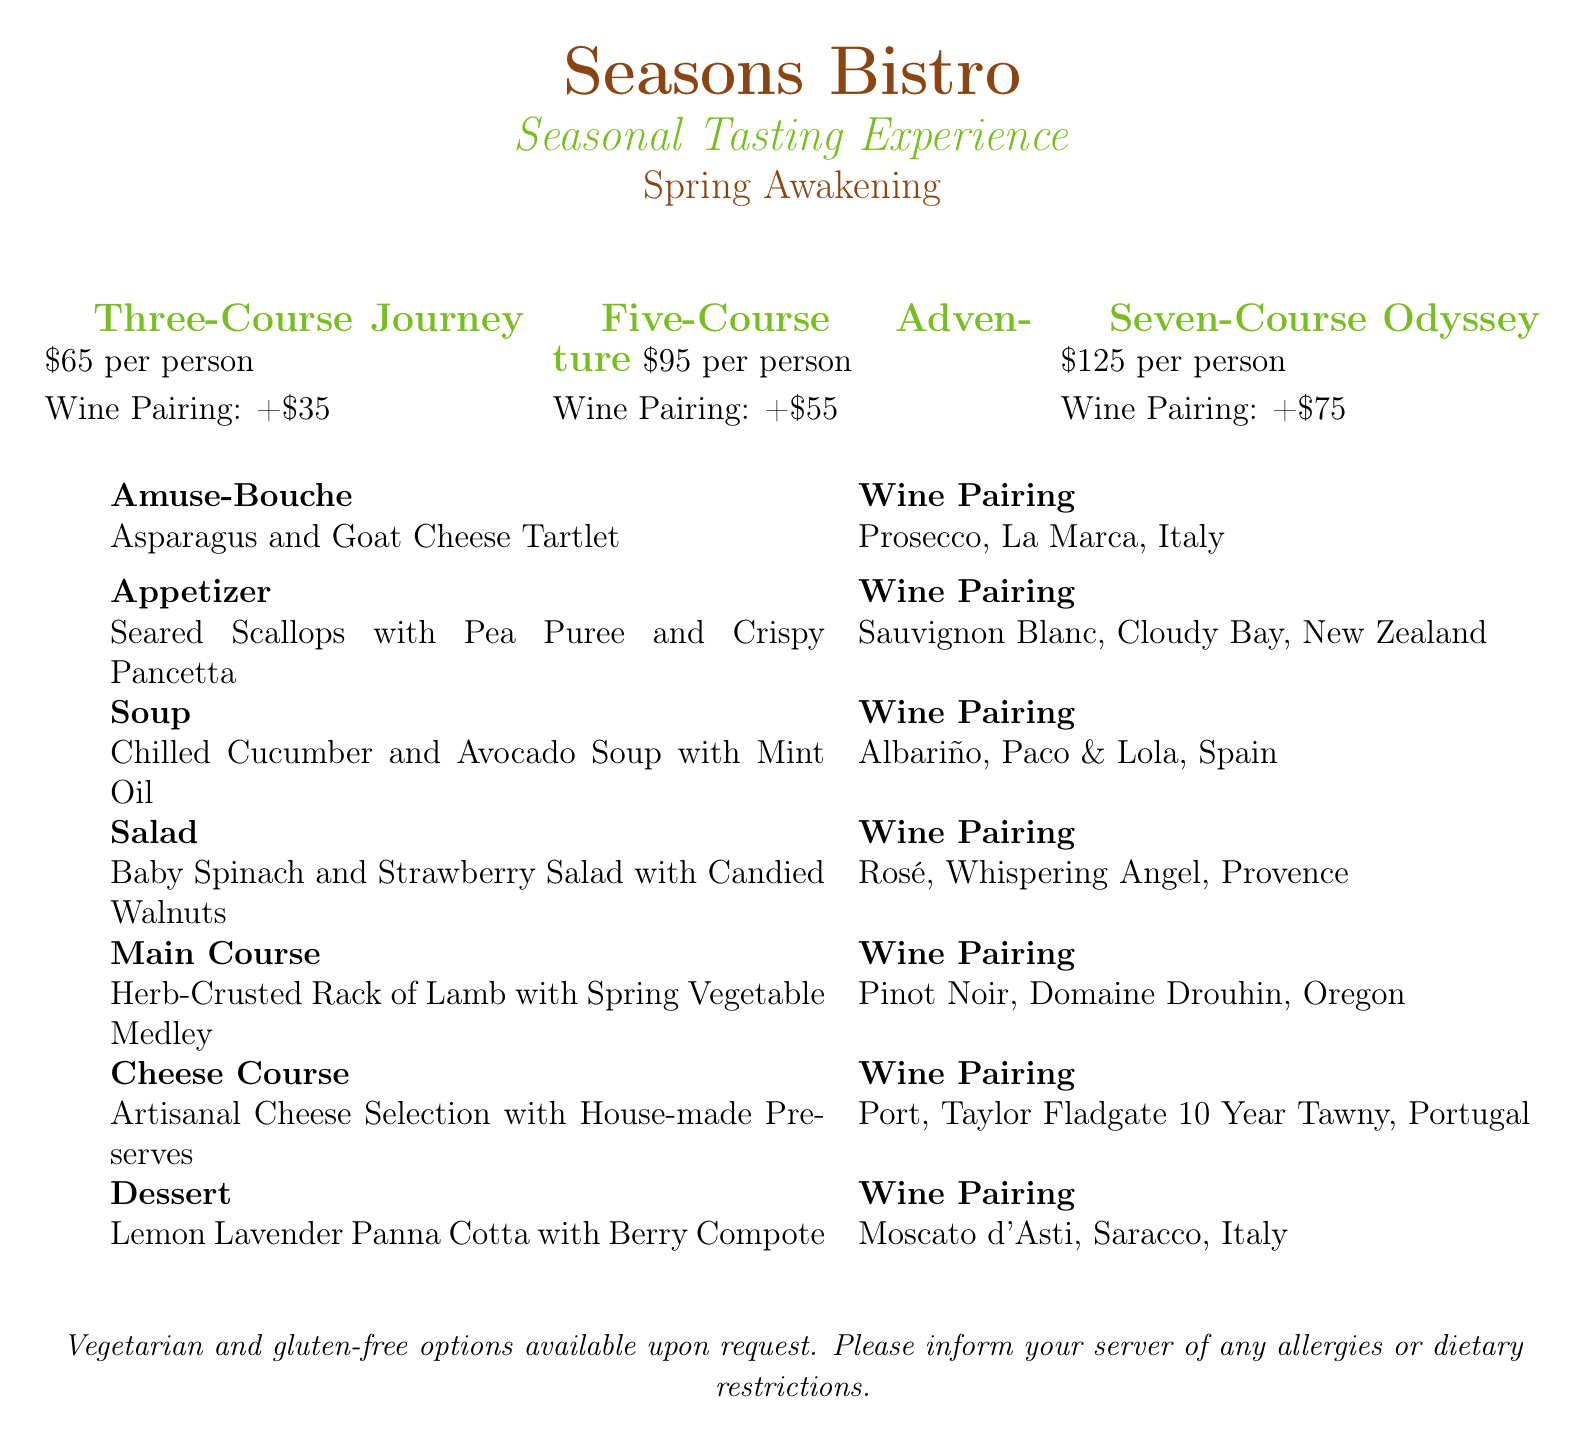what is the name of the restaurant? The name of the restaurant is presented at the top of the document.
Answer: Seasons Bistro what is the price for the three-course journey? The price for the three-course journey is provided in the pricing options section.
Answer: $65 per person how much is the wine pairing for the five-course adventure? The cost for the wine pairing is stated next to the five-course adventure in the pricing options section.
Answer: +$55 which wine is paired with the main course? The specific wine pairing for the main course can be found in the wine pairings provided in the menu.
Answer: Pinot Noir, Domaine Drouhin, Oregon how many courses are included in the seven-course odyssey? The number of courses is indicated in the name of the tasting experience.
Answer: Seven what is offered in the amuse-bouche section? The amuse-bouche section lists the specific dish that will be served.
Answer: Asparagus and Goat Cheese Tartlet are vegetarian options available? This information is mentioned in the notes at the bottom of the menu.
Answer: Yes what is the dessert option on the menu? The dessert is described in the dessert section of the menu.
Answer: Lemon Lavender Panna Cotta with Berry Compote 